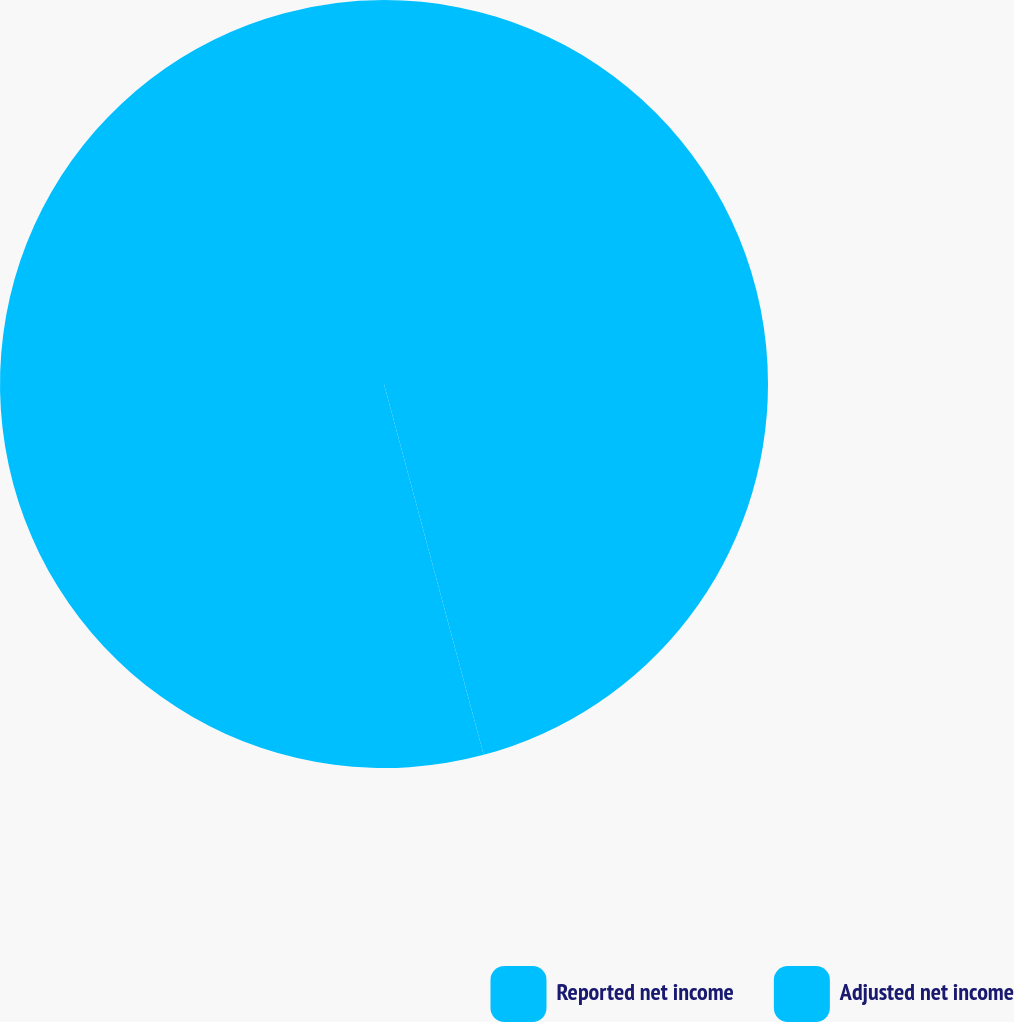Convert chart to OTSL. <chart><loc_0><loc_0><loc_500><loc_500><pie_chart><fcel>Reported net income<fcel>Adjusted net income<nl><fcel>45.82%<fcel>54.18%<nl></chart> 